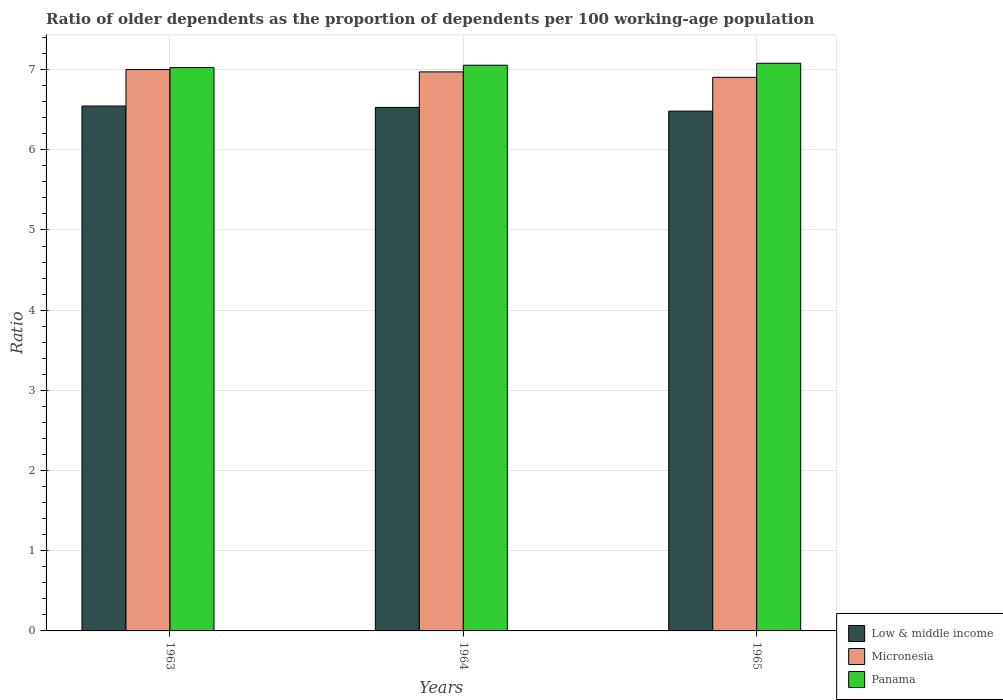How many different coloured bars are there?
Provide a succinct answer. 3. How many groups of bars are there?
Keep it short and to the point. 3. Are the number of bars per tick equal to the number of legend labels?
Offer a very short reply. Yes. Are the number of bars on each tick of the X-axis equal?
Offer a very short reply. Yes. How many bars are there on the 2nd tick from the right?
Give a very brief answer. 3. What is the label of the 2nd group of bars from the left?
Offer a very short reply. 1964. What is the age dependency ratio(old) in Micronesia in 1964?
Provide a succinct answer. 6.97. Across all years, what is the maximum age dependency ratio(old) in Micronesia?
Your answer should be compact. 7. Across all years, what is the minimum age dependency ratio(old) in Panama?
Your answer should be very brief. 7.02. In which year was the age dependency ratio(old) in Micronesia maximum?
Offer a very short reply. 1963. What is the total age dependency ratio(old) in Low & middle income in the graph?
Your response must be concise. 19.56. What is the difference between the age dependency ratio(old) in Micronesia in 1963 and that in 1964?
Provide a short and direct response. 0.03. What is the difference between the age dependency ratio(old) in Low & middle income in 1963 and the age dependency ratio(old) in Micronesia in 1964?
Your response must be concise. -0.43. What is the average age dependency ratio(old) in Low & middle income per year?
Your answer should be very brief. 6.52. In the year 1963, what is the difference between the age dependency ratio(old) in Panama and age dependency ratio(old) in Micronesia?
Offer a very short reply. 0.02. In how many years, is the age dependency ratio(old) in Panama greater than 6.2?
Give a very brief answer. 3. What is the ratio of the age dependency ratio(old) in Panama in 1963 to that in 1964?
Your response must be concise. 1. Is the difference between the age dependency ratio(old) in Panama in 1963 and 1964 greater than the difference between the age dependency ratio(old) in Micronesia in 1963 and 1964?
Provide a succinct answer. No. What is the difference between the highest and the second highest age dependency ratio(old) in Micronesia?
Ensure brevity in your answer.  0.03. What is the difference between the highest and the lowest age dependency ratio(old) in Low & middle income?
Provide a short and direct response. 0.06. In how many years, is the age dependency ratio(old) in Low & middle income greater than the average age dependency ratio(old) in Low & middle income taken over all years?
Your answer should be very brief. 2. Is the sum of the age dependency ratio(old) in Low & middle income in 1964 and 1965 greater than the maximum age dependency ratio(old) in Panama across all years?
Ensure brevity in your answer.  Yes. What does the 3rd bar from the left in 1964 represents?
Provide a short and direct response. Panama. Is it the case that in every year, the sum of the age dependency ratio(old) in Low & middle income and age dependency ratio(old) in Panama is greater than the age dependency ratio(old) in Micronesia?
Offer a very short reply. Yes. How many years are there in the graph?
Give a very brief answer. 3. What is the difference between two consecutive major ticks on the Y-axis?
Offer a terse response. 1. Does the graph contain any zero values?
Keep it short and to the point. No. Does the graph contain grids?
Offer a very short reply. Yes. How many legend labels are there?
Provide a short and direct response. 3. What is the title of the graph?
Offer a very short reply. Ratio of older dependents as the proportion of dependents per 100 working-age population. Does "Peru" appear as one of the legend labels in the graph?
Make the answer very short. No. What is the label or title of the X-axis?
Provide a short and direct response. Years. What is the label or title of the Y-axis?
Provide a short and direct response. Ratio. What is the Ratio of Low & middle income in 1963?
Keep it short and to the point. 6.55. What is the Ratio in Micronesia in 1963?
Your response must be concise. 7. What is the Ratio of Panama in 1963?
Make the answer very short. 7.02. What is the Ratio of Low & middle income in 1964?
Provide a succinct answer. 6.53. What is the Ratio of Micronesia in 1964?
Ensure brevity in your answer.  6.97. What is the Ratio in Panama in 1964?
Your response must be concise. 7.05. What is the Ratio in Low & middle income in 1965?
Offer a terse response. 6.48. What is the Ratio of Micronesia in 1965?
Your answer should be compact. 6.9. What is the Ratio of Panama in 1965?
Make the answer very short. 7.08. Across all years, what is the maximum Ratio in Low & middle income?
Your answer should be compact. 6.55. Across all years, what is the maximum Ratio of Micronesia?
Keep it short and to the point. 7. Across all years, what is the maximum Ratio of Panama?
Give a very brief answer. 7.08. Across all years, what is the minimum Ratio of Low & middle income?
Your answer should be compact. 6.48. Across all years, what is the minimum Ratio in Micronesia?
Provide a short and direct response. 6.9. Across all years, what is the minimum Ratio of Panama?
Offer a very short reply. 7.02. What is the total Ratio in Low & middle income in the graph?
Make the answer very short. 19.56. What is the total Ratio in Micronesia in the graph?
Your response must be concise. 20.88. What is the total Ratio of Panama in the graph?
Give a very brief answer. 21.16. What is the difference between the Ratio in Low & middle income in 1963 and that in 1964?
Your answer should be very brief. 0.02. What is the difference between the Ratio in Micronesia in 1963 and that in 1964?
Your answer should be compact. 0.03. What is the difference between the Ratio of Panama in 1963 and that in 1964?
Make the answer very short. -0.03. What is the difference between the Ratio in Low & middle income in 1963 and that in 1965?
Provide a short and direct response. 0.06. What is the difference between the Ratio in Micronesia in 1963 and that in 1965?
Your answer should be compact. 0.1. What is the difference between the Ratio in Panama in 1963 and that in 1965?
Offer a very short reply. -0.05. What is the difference between the Ratio in Low & middle income in 1964 and that in 1965?
Ensure brevity in your answer.  0.05. What is the difference between the Ratio of Micronesia in 1964 and that in 1965?
Offer a terse response. 0.07. What is the difference between the Ratio in Panama in 1964 and that in 1965?
Your answer should be compact. -0.02. What is the difference between the Ratio of Low & middle income in 1963 and the Ratio of Micronesia in 1964?
Your answer should be compact. -0.43. What is the difference between the Ratio of Low & middle income in 1963 and the Ratio of Panama in 1964?
Your response must be concise. -0.51. What is the difference between the Ratio in Micronesia in 1963 and the Ratio in Panama in 1964?
Offer a terse response. -0.05. What is the difference between the Ratio of Low & middle income in 1963 and the Ratio of Micronesia in 1965?
Your response must be concise. -0.36. What is the difference between the Ratio of Low & middle income in 1963 and the Ratio of Panama in 1965?
Your response must be concise. -0.53. What is the difference between the Ratio of Micronesia in 1963 and the Ratio of Panama in 1965?
Ensure brevity in your answer.  -0.08. What is the difference between the Ratio of Low & middle income in 1964 and the Ratio of Micronesia in 1965?
Your answer should be very brief. -0.37. What is the difference between the Ratio of Low & middle income in 1964 and the Ratio of Panama in 1965?
Give a very brief answer. -0.55. What is the difference between the Ratio of Micronesia in 1964 and the Ratio of Panama in 1965?
Make the answer very short. -0.11. What is the average Ratio of Low & middle income per year?
Provide a succinct answer. 6.52. What is the average Ratio in Micronesia per year?
Your answer should be very brief. 6.96. What is the average Ratio of Panama per year?
Your answer should be very brief. 7.05. In the year 1963, what is the difference between the Ratio in Low & middle income and Ratio in Micronesia?
Your answer should be compact. -0.46. In the year 1963, what is the difference between the Ratio in Low & middle income and Ratio in Panama?
Provide a short and direct response. -0.48. In the year 1963, what is the difference between the Ratio of Micronesia and Ratio of Panama?
Keep it short and to the point. -0.02. In the year 1964, what is the difference between the Ratio of Low & middle income and Ratio of Micronesia?
Provide a short and direct response. -0.44. In the year 1964, what is the difference between the Ratio in Low & middle income and Ratio in Panama?
Your answer should be very brief. -0.53. In the year 1964, what is the difference between the Ratio in Micronesia and Ratio in Panama?
Give a very brief answer. -0.08. In the year 1965, what is the difference between the Ratio of Low & middle income and Ratio of Micronesia?
Offer a very short reply. -0.42. In the year 1965, what is the difference between the Ratio of Low & middle income and Ratio of Panama?
Your answer should be compact. -0.6. In the year 1965, what is the difference between the Ratio of Micronesia and Ratio of Panama?
Your response must be concise. -0.18. What is the ratio of the Ratio in Low & middle income in 1963 to that in 1964?
Ensure brevity in your answer.  1. What is the ratio of the Ratio of Micronesia in 1963 to that in 1964?
Keep it short and to the point. 1. What is the ratio of the Ratio in Panama in 1963 to that in 1964?
Offer a very short reply. 1. What is the ratio of the Ratio of Low & middle income in 1963 to that in 1965?
Make the answer very short. 1.01. What is the ratio of the Ratio of Micronesia in 1963 to that in 1965?
Provide a short and direct response. 1.01. What is the ratio of the Ratio of Panama in 1963 to that in 1965?
Give a very brief answer. 0.99. What is the ratio of the Ratio in Low & middle income in 1964 to that in 1965?
Ensure brevity in your answer.  1.01. What is the ratio of the Ratio in Micronesia in 1964 to that in 1965?
Keep it short and to the point. 1.01. What is the difference between the highest and the second highest Ratio in Low & middle income?
Provide a succinct answer. 0.02. What is the difference between the highest and the second highest Ratio in Micronesia?
Provide a short and direct response. 0.03. What is the difference between the highest and the second highest Ratio of Panama?
Your answer should be very brief. 0.02. What is the difference between the highest and the lowest Ratio of Low & middle income?
Keep it short and to the point. 0.06. What is the difference between the highest and the lowest Ratio in Micronesia?
Your answer should be compact. 0.1. What is the difference between the highest and the lowest Ratio of Panama?
Keep it short and to the point. 0.05. 